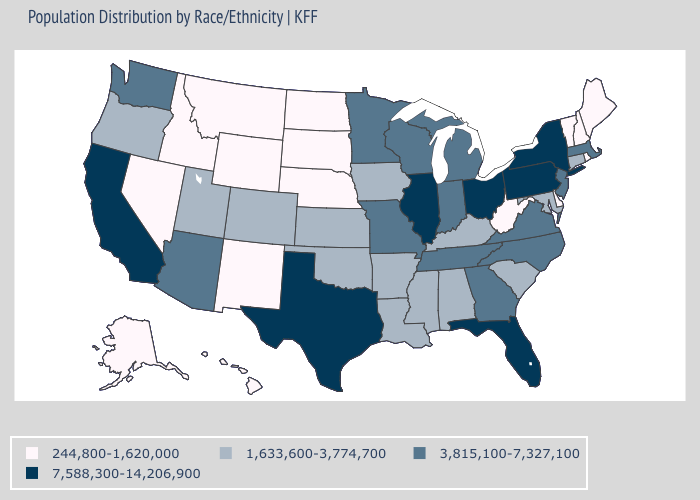What is the value of Colorado?
Concise answer only. 1,633,600-3,774,700. Name the states that have a value in the range 1,633,600-3,774,700?
Quick response, please. Alabama, Arkansas, Colorado, Connecticut, Iowa, Kansas, Kentucky, Louisiana, Maryland, Mississippi, Oklahoma, Oregon, South Carolina, Utah. What is the value of West Virginia?
Answer briefly. 244,800-1,620,000. Which states have the highest value in the USA?
Keep it brief. California, Florida, Illinois, New York, Ohio, Pennsylvania, Texas. Name the states that have a value in the range 3,815,100-7,327,100?
Write a very short answer. Arizona, Georgia, Indiana, Massachusetts, Michigan, Minnesota, Missouri, New Jersey, North Carolina, Tennessee, Virginia, Washington, Wisconsin. Does New Jersey have the highest value in the USA?
Quick response, please. No. What is the value of Oregon?
Concise answer only. 1,633,600-3,774,700. Name the states that have a value in the range 1,633,600-3,774,700?
Short answer required. Alabama, Arkansas, Colorado, Connecticut, Iowa, Kansas, Kentucky, Louisiana, Maryland, Mississippi, Oklahoma, Oregon, South Carolina, Utah. Does Ohio have a lower value than Wyoming?
Quick response, please. No. Name the states that have a value in the range 3,815,100-7,327,100?
Short answer required. Arizona, Georgia, Indiana, Massachusetts, Michigan, Minnesota, Missouri, New Jersey, North Carolina, Tennessee, Virginia, Washington, Wisconsin. Name the states that have a value in the range 244,800-1,620,000?
Write a very short answer. Alaska, Delaware, Hawaii, Idaho, Maine, Montana, Nebraska, Nevada, New Hampshire, New Mexico, North Dakota, Rhode Island, South Dakota, Vermont, West Virginia, Wyoming. What is the lowest value in states that border Maine?
Answer briefly. 244,800-1,620,000. Does Rhode Island have the lowest value in the USA?
Be succinct. Yes. Among the states that border Kansas , does Missouri have the highest value?
Give a very brief answer. Yes. Among the states that border Kentucky , does Tennessee have the lowest value?
Answer briefly. No. 